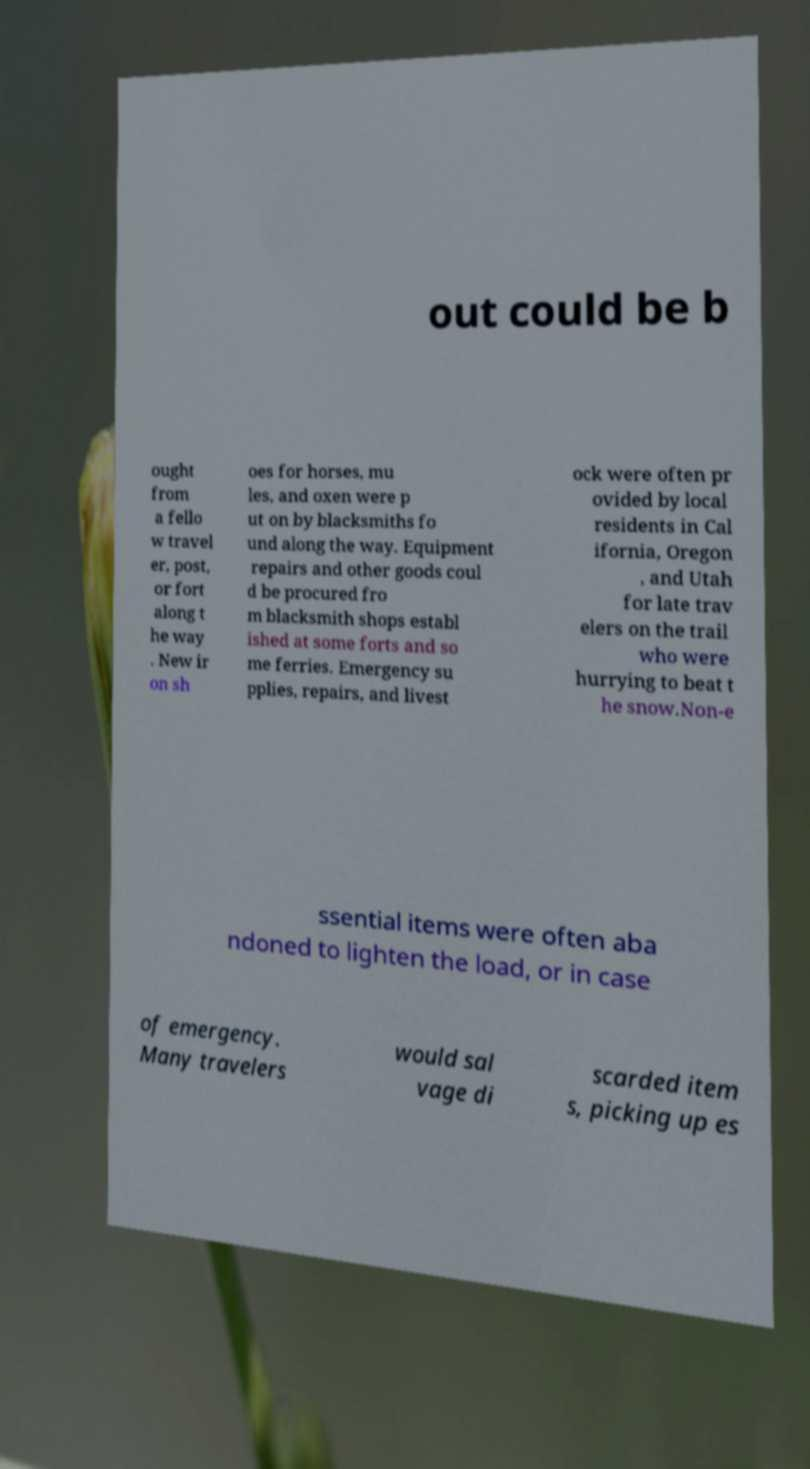I need the written content from this picture converted into text. Can you do that? out could be b ought from a fello w travel er, post, or fort along t he way . New ir on sh oes for horses, mu les, and oxen were p ut on by blacksmiths fo und along the way. Equipment repairs and other goods coul d be procured fro m blacksmith shops establ ished at some forts and so me ferries. Emergency su pplies, repairs, and livest ock were often pr ovided by local residents in Cal ifornia, Oregon , and Utah for late trav elers on the trail who were hurrying to beat t he snow.Non-e ssential items were often aba ndoned to lighten the load, or in case of emergency. Many travelers would sal vage di scarded item s, picking up es 